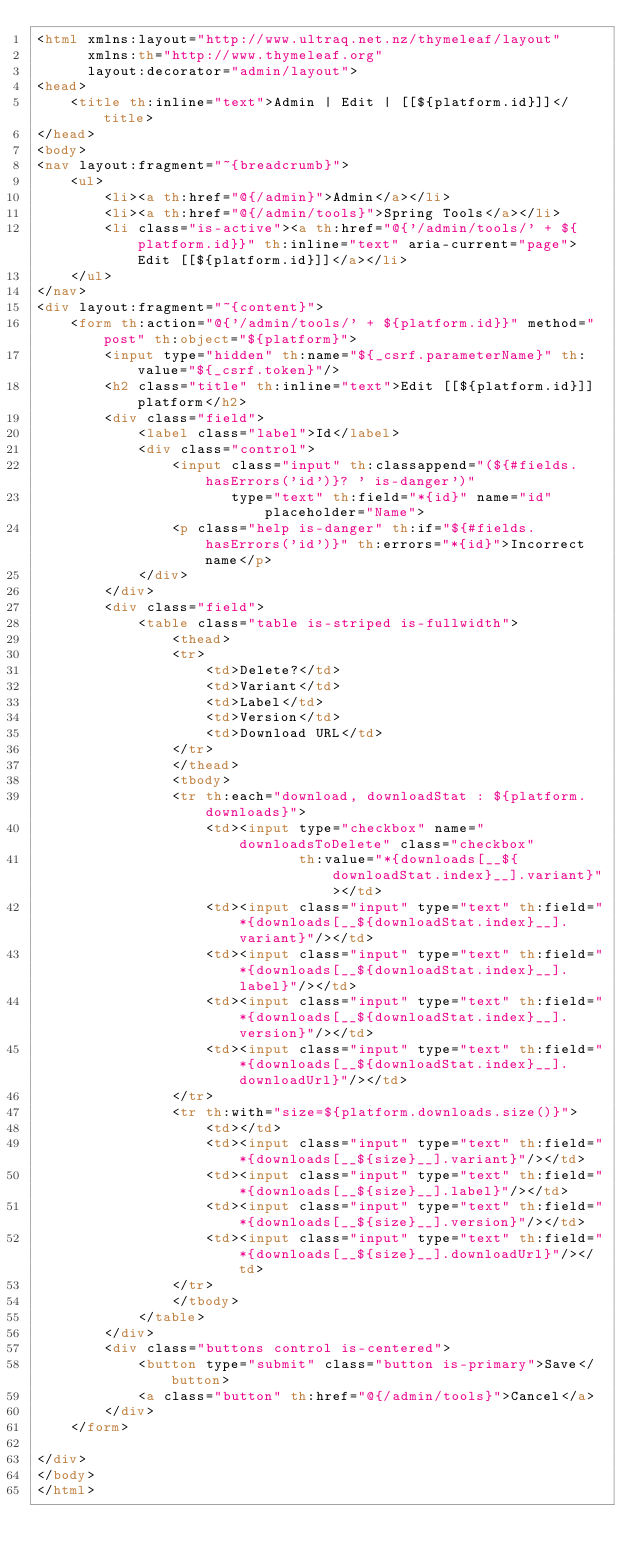Convert code to text. <code><loc_0><loc_0><loc_500><loc_500><_HTML_><html xmlns:layout="http://www.ultraq.net.nz/thymeleaf/layout"
      xmlns:th="http://www.thymeleaf.org"
      layout:decorator="admin/layout">
<head>
    <title th:inline="text">Admin | Edit | [[${platform.id}]]</title>
</head>
<body>
<nav layout:fragment="~{breadcrumb}">
    <ul>
        <li><a th:href="@{/admin}">Admin</a></li>
        <li><a th:href="@{/admin/tools}">Spring Tools</a></li>
        <li class="is-active"><a th:href="@{'/admin/tools/' + ${platform.id}}" th:inline="text" aria-current="page">Edit [[${platform.id}]]</a></li>
    </ul>
</nav>
<div layout:fragment="~{content}">
    <form th:action="@{'/admin/tools/' + ${platform.id}}" method="post" th:object="${platform}">
        <input type="hidden" th:name="${_csrf.parameterName}" th:value="${_csrf.token}"/>
        <h2 class="title" th:inline="text">Edit [[${platform.id}]] platform</h2>
        <div class="field">
            <label class="label">Id</label>
            <div class="control">
                <input class="input" th:classappend="(${#fields.hasErrors('id')}? ' is-danger')"
                       type="text" th:field="*{id}" name="id" placeholder="Name">
                <p class="help is-danger" th:if="${#fields.hasErrors('id')}" th:errors="*{id}">Incorrect name</p>
            </div>
        </div>
        <div class="field">
            <table class="table is-striped is-fullwidth">
                <thead>
                <tr>
                    <td>Delete?</td>
                    <td>Variant</td>
                    <td>Label</td>
                    <td>Version</td>
                    <td>Download URL</td>
                </tr>
                </thead>
                <tbody>
                <tr th:each="download, downloadStat : ${platform.downloads}">
                    <td><input type="checkbox" name="downloadsToDelete" class="checkbox"
                               th:value="*{downloads[__${downloadStat.index}__].variant}"></td>
                    <td><input class="input" type="text" th:field="*{downloads[__${downloadStat.index}__].variant}"/></td>
                    <td><input class="input" type="text" th:field="*{downloads[__${downloadStat.index}__].label}"/></td>
                    <td><input class="input" type="text" th:field="*{downloads[__${downloadStat.index}__].version}"/></td>
                    <td><input class="input" type="text" th:field="*{downloads[__${downloadStat.index}__].downloadUrl}"/></td>
                </tr>
                <tr th:with="size=${platform.downloads.size()}">
                    <td></td>
                    <td><input class="input" type="text" th:field="*{downloads[__${size}__].variant}"/></td>
                    <td><input class="input" type="text" th:field="*{downloads[__${size}__].label}"/></td>
                    <td><input class="input" type="text" th:field="*{downloads[__${size}__].version}"/></td>
                    <td><input class="input" type="text" th:field="*{downloads[__${size}__].downloadUrl}"/></td>
                </tr>
                </tbody>
            </table>
        </div>
        <div class="buttons control is-centered">
            <button type="submit" class="button is-primary">Save</button>
            <a class="button" th:href="@{/admin/tools}">Cancel</a>
        </div>
    </form>

</div>
</body>
</html>
</code> 